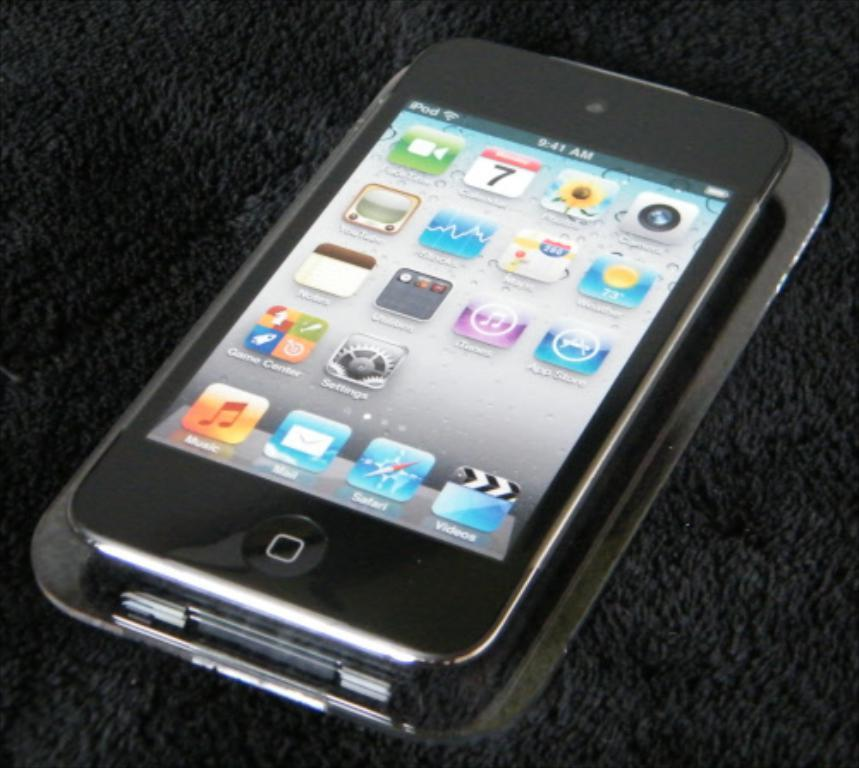<image>
Describe the image concisely. 9:41 AM is the time shown on the digital display of this smart phone. 